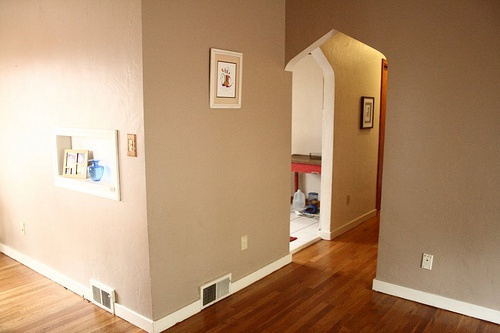Describe the objects in this image and their specific colors. I can see vase in tan, lightblue, and darkgray tones and bottle in tan, darkgray, lightgray, and gray tones in this image. 